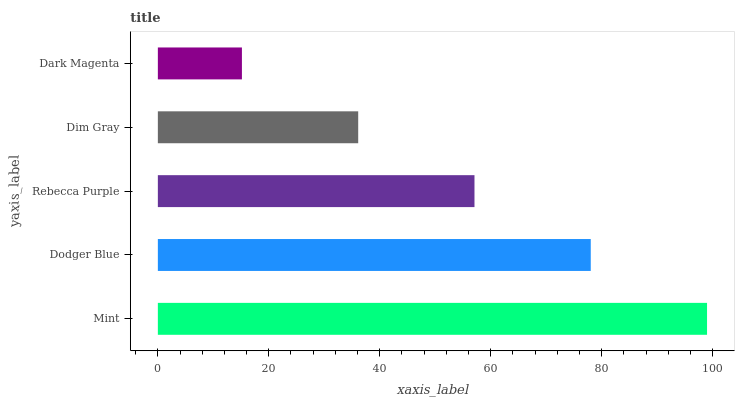Is Dark Magenta the minimum?
Answer yes or no. Yes. Is Mint the maximum?
Answer yes or no. Yes. Is Dodger Blue the minimum?
Answer yes or no. No. Is Dodger Blue the maximum?
Answer yes or no. No. Is Mint greater than Dodger Blue?
Answer yes or no. Yes. Is Dodger Blue less than Mint?
Answer yes or no. Yes. Is Dodger Blue greater than Mint?
Answer yes or no. No. Is Mint less than Dodger Blue?
Answer yes or no. No. Is Rebecca Purple the high median?
Answer yes or no. Yes. Is Rebecca Purple the low median?
Answer yes or no. Yes. Is Dim Gray the high median?
Answer yes or no. No. Is Dim Gray the low median?
Answer yes or no. No. 